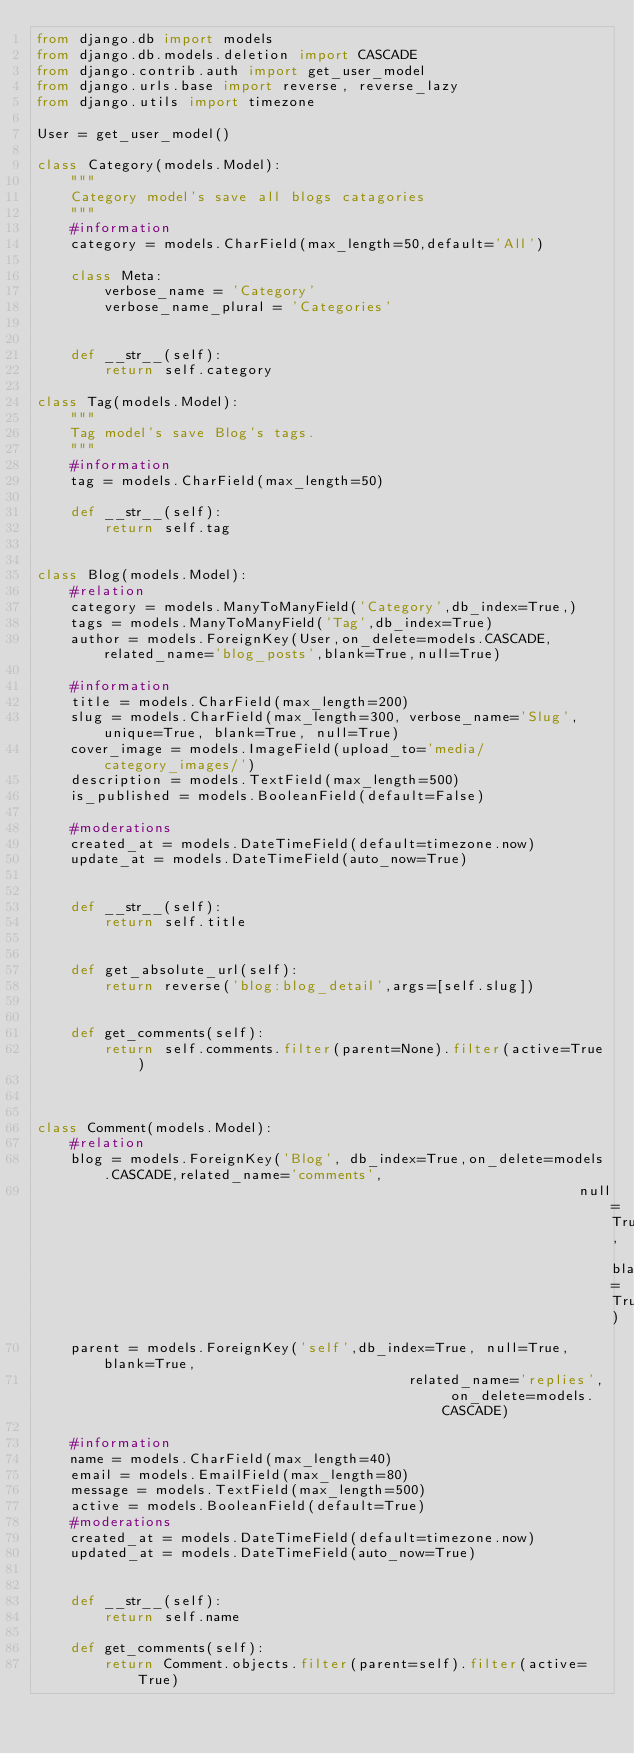<code> <loc_0><loc_0><loc_500><loc_500><_Python_>from django.db import models
from django.db.models.deletion import CASCADE
from django.contrib.auth import get_user_model
from django.urls.base import reverse, reverse_lazy
from django.utils import timezone

User = get_user_model()

class Category(models.Model):
    """
    Category model's save all blogs catagories
    """
    #information
    category = models.CharField(max_length=50,default='All')

    class Meta:
        verbose_name = 'Category'
        verbose_name_plural = 'Categories'


    def __str__(self):
        return self.category

class Tag(models.Model):
    """
    Tag model's save Blog's tags.
    """
    #information
    tag = models.CharField(max_length=50)

    def __str__(self):
        return self.tag


class Blog(models.Model):
    #relation
    category = models.ManyToManyField('Category',db_index=True,)
    tags = models.ManyToManyField('Tag',db_index=True)
    author = models.ForeignKey(User,on_delete=models.CASCADE,related_name='blog_posts',blank=True,null=True)

    #information
    title = models.CharField(max_length=200)
    slug = models.CharField(max_length=300, verbose_name='Slug', unique=True, blank=True, null=True)
    cover_image = models.ImageField(upload_to='media/category_images/')
    description = models.TextField(max_length=500)
    is_published = models.BooleanField(default=False)

    #moderations
    created_at = models.DateTimeField(default=timezone.now)
    update_at = models.DateTimeField(auto_now=True)
   

    def __str__(self):
        return self.title


    def get_absolute_url(self):
        return reverse('blog:blog_detail',args=[self.slug])

    
    def get_comments(self):
        return self.comments.filter(parent=None).filter(active=True)
        


class Comment(models.Model):    
    #relation
    blog = models.ForeignKey('Blog', db_index=True,on_delete=models.CASCADE,related_name='comments',
                                                                null=True, blank=True)
    parent = models.ForeignKey('self',db_index=True, null=True, blank=True,
                                            related_name='replies', on_delete=models.CASCADE)

    #information
    name = models.CharField(max_length=40)
    email = models.EmailField(max_length=80)
    message = models.TextField(max_length=500)
    active = models.BooleanField(default=True)
    #moderations
    created_at = models.DateTimeField(default=timezone.now)
    updated_at = models.DateTimeField(auto_now=True)


    def __str__(self):
        return self.name

    def get_comments(self):
        return Comment.objects.filter(parent=self).filter(active=True)</code> 